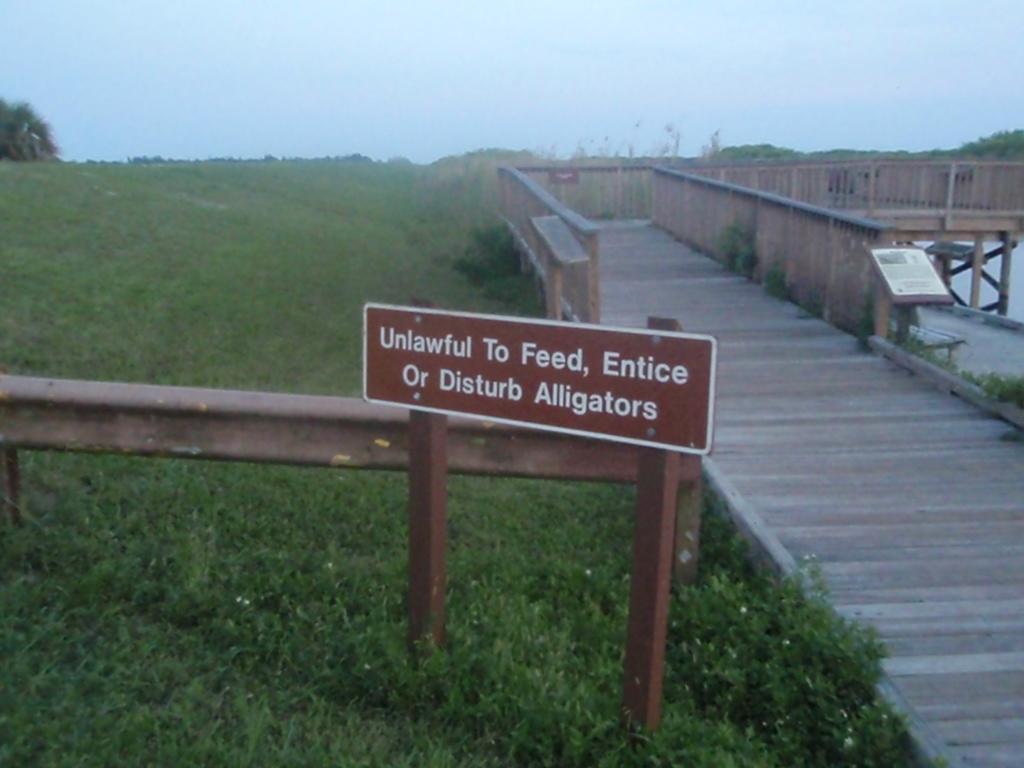Can you describe this image briefly? In this image in the front there's grass on the ground. In the center there is a board with some text written on it and on the right side there is a walkway and there is a board with some text written on it. In the background there are trees. 